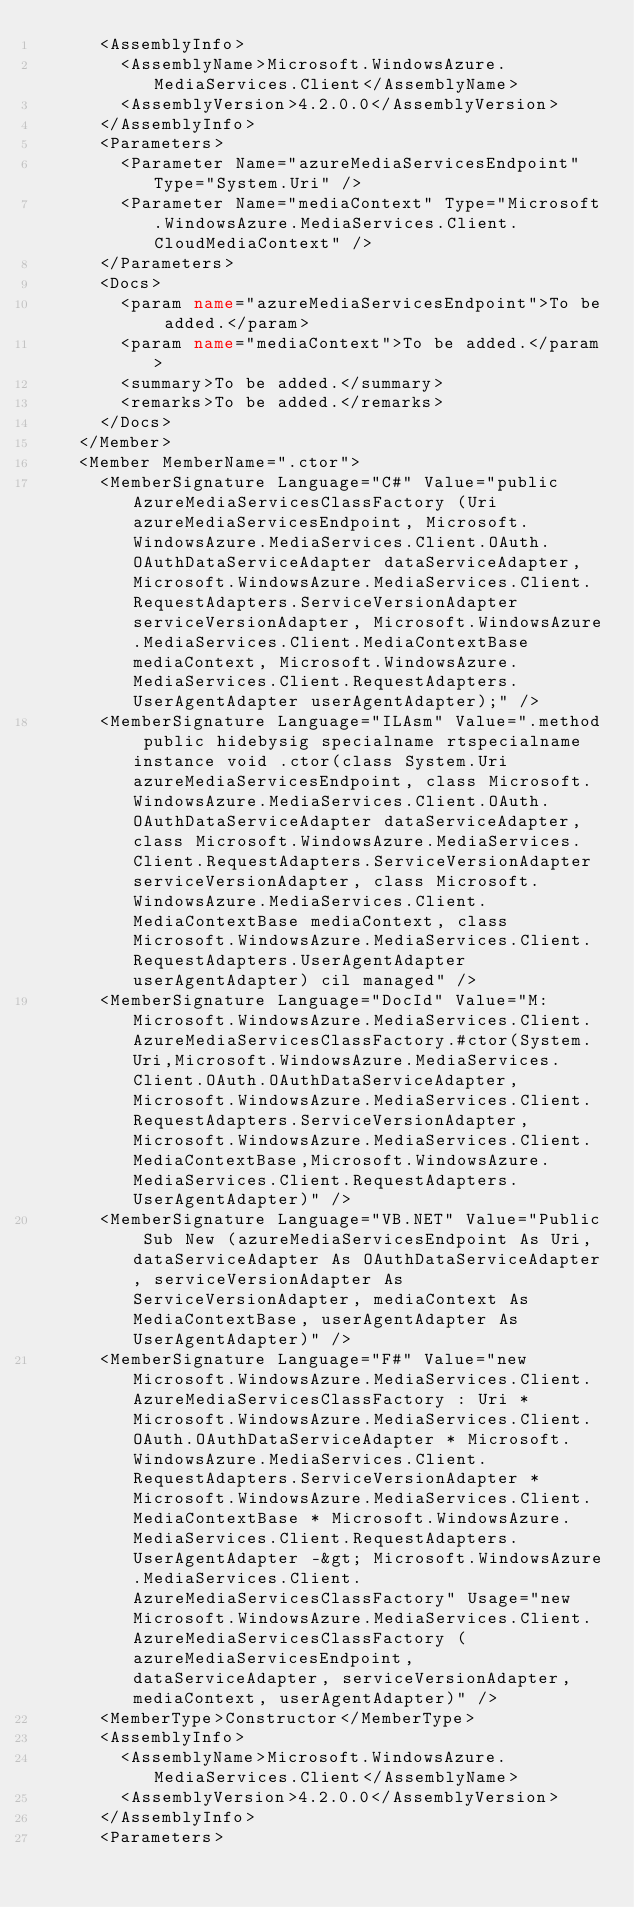Convert code to text. <code><loc_0><loc_0><loc_500><loc_500><_XML_>      <AssemblyInfo>
        <AssemblyName>Microsoft.WindowsAzure.MediaServices.Client</AssemblyName>
        <AssemblyVersion>4.2.0.0</AssemblyVersion>
      </AssemblyInfo>
      <Parameters>
        <Parameter Name="azureMediaServicesEndpoint" Type="System.Uri" />
        <Parameter Name="mediaContext" Type="Microsoft.WindowsAzure.MediaServices.Client.CloudMediaContext" />
      </Parameters>
      <Docs>
        <param name="azureMediaServicesEndpoint">To be added.</param>
        <param name="mediaContext">To be added.</param>
        <summary>To be added.</summary>
        <remarks>To be added.</remarks>
      </Docs>
    </Member>
    <Member MemberName=".ctor">
      <MemberSignature Language="C#" Value="public AzureMediaServicesClassFactory (Uri azureMediaServicesEndpoint, Microsoft.WindowsAzure.MediaServices.Client.OAuth.OAuthDataServiceAdapter dataServiceAdapter, Microsoft.WindowsAzure.MediaServices.Client.RequestAdapters.ServiceVersionAdapter serviceVersionAdapter, Microsoft.WindowsAzure.MediaServices.Client.MediaContextBase mediaContext, Microsoft.WindowsAzure.MediaServices.Client.RequestAdapters.UserAgentAdapter userAgentAdapter);" />
      <MemberSignature Language="ILAsm" Value=".method public hidebysig specialname rtspecialname instance void .ctor(class System.Uri azureMediaServicesEndpoint, class Microsoft.WindowsAzure.MediaServices.Client.OAuth.OAuthDataServiceAdapter dataServiceAdapter, class Microsoft.WindowsAzure.MediaServices.Client.RequestAdapters.ServiceVersionAdapter serviceVersionAdapter, class Microsoft.WindowsAzure.MediaServices.Client.MediaContextBase mediaContext, class Microsoft.WindowsAzure.MediaServices.Client.RequestAdapters.UserAgentAdapter userAgentAdapter) cil managed" />
      <MemberSignature Language="DocId" Value="M:Microsoft.WindowsAzure.MediaServices.Client.AzureMediaServicesClassFactory.#ctor(System.Uri,Microsoft.WindowsAzure.MediaServices.Client.OAuth.OAuthDataServiceAdapter,Microsoft.WindowsAzure.MediaServices.Client.RequestAdapters.ServiceVersionAdapter,Microsoft.WindowsAzure.MediaServices.Client.MediaContextBase,Microsoft.WindowsAzure.MediaServices.Client.RequestAdapters.UserAgentAdapter)" />
      <MemberSignature Language="VB.NET" Value="Public Sub New (azureMediaServicesEndpoint As Uri, dataServiceAdapter As OAuthDataServiceAdapter, serviceVersionAdapter As ServiceVersionAdapter, mediaContext As MediaContextBase, userAgentAdapter As UserAgentAdapter)" />
      <MemberSignature Language="F#" Value="new Microsoft.WindowsAzure.MediaServices.Client.AzureMediaServicesClassFactory : Uri * Microsoft.WindowsAzure.MediaServices.Client.OAuth.OAuthDataServiceAdapter * Microsoft.WindowsAzure.MediaServices.Client.RequestAdapters.ServiceVersionAdapter * Microsoft.WindowsAzure.MediaServices.Client.MediaContextBase * Microsoft.WindowsAzure.MediaServices.Client.RequestAdapters.UserAgentAdapter -&gt; Microsoft.WindowsAzure.MediaServices.Client.AzureMediaServicesClassFactory" Usage="new Microsoft.WindowsAzure.MediaServices.Client.AzureMediaServicesClassFactory (azureMediaServicesEndpoint, dataServiceAdapter, serviceVersionAdapter, mediaContext, userAgentAdapter)" />
      <MemberType>Constructor</MemberType>
      <AssemblyInfo>
        <AssemblyName>Microsoft.WindowsAzure.MediaServices.Client</AssemblyName>
        <AssemblyVersion>4.2.0.0</AssemblyVersion>
      </AssemblyInfo>
      <Parameters></code> 